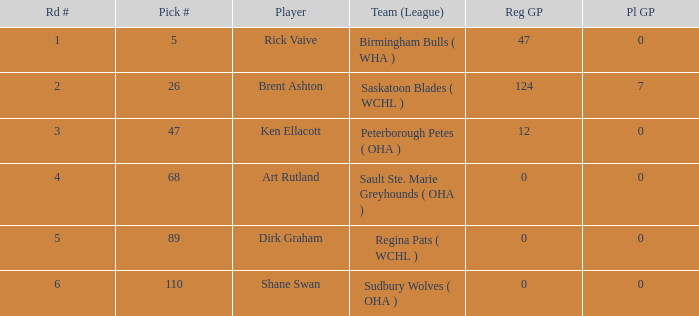How many reg GP for rick vaive in round 1? None. 